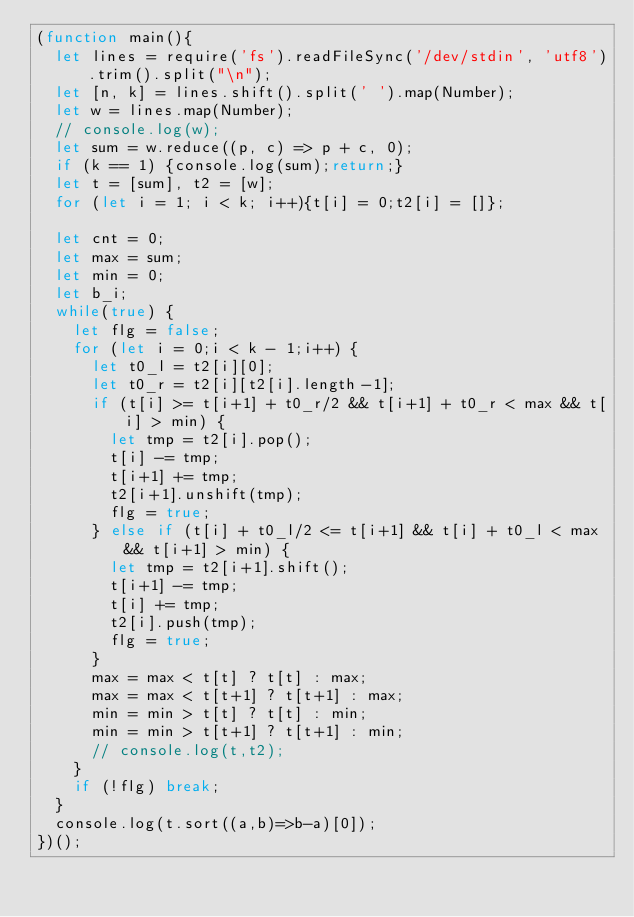<code> <loc_0><loc_0><loc_500><loc_500><_JavaScript_>(function main(){
  let lines = require('fs').readFileSync('/dev/stdin', 'utf8').trim().split("\n");
  let [n, k] = lines.shift().split(' ').map(Number);
  let w = lines.map(Number);
  // console.log(w);
  let sum = w.reduce((p, c) => p + c, 0);
  if (k == 1) {console.log(sum);return;}
  let t = [sum], t2 = [w];
  for (let i = 1; i < k; i++){t[i] = 0;t2[i] = []};

  let cnt = 0;
  let max = sum;
  let min = 0;
  let b_i;
  while(true) {
    let flg = false;
    for (let i = 0;i < k - 1;i++) {
      let t0_l = t2[i][0];
      let t0_r = t2[i][t2[i].length-1];
      if (t[i] >= t[i+1] + t0_r/2 && t[i+1] + t0_r < max && t[i] > min) {
        let tmp = t2[i].pop();
        t[i] -= tmp;
        t[i+1] += tmp;
        t2[i+1].unshift(tmp);
        flg = true;
      } else if (t[i] + t0_l/2 <= t[i+1] && t[i] + t0_l < max && t[i+1] > min) {
        let tmp = t2[i+1].shift();
        t[i+1] -= tmp;
        t[i] += tmp;
        t2[i].push(tmp);
        flg = true;
      }
      max = max < t[t] ? t[t] : max;
      max = max < t[t+1] ? t[t+1] : max;
      min = min > t[t] ? t[t] : min;
      min = min > t[t+1] ? t[t+1] : min;
      // console.log(t,t2);
    }
    if (!flg) break;
  }
  console.log(t.sort((a,b)=>b-a)[0]);
})();

</code> 